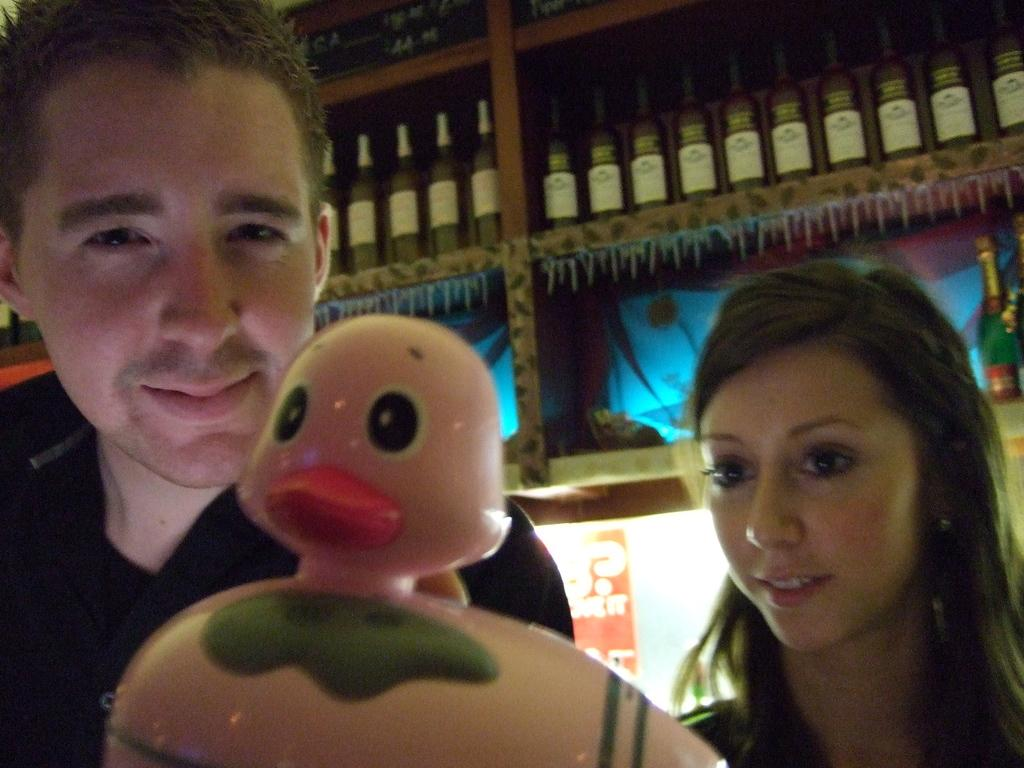Who are the people in the image? There is a woman and a man in the image. What is in front of the woman and man? There is a toy in front of the woman and man. What can be seen behind the woman and man? There is a rack visible in the image. What is stored on the rack? There are bottles in the rack. What type of authority does the woman have over the man in the image? There is no indication of authority or power dynamics between the woman and the man in the image. --- Facts: 1. There is a car in the image. 2. The car is parked on the street. 3. There are trees on both sides of the street. 4. The sky is visible in the image. 5. There are clouds in the sky. Absurd Topics: elephant, dance, ocean Conversation: What is the main subject of the image? The main subject of the image is a car. Where is the car located in the image? The car is parked on the street. What can be seen on both sides of the street? There are trees on both sides of the street. What is visible in the background of the image? The sky is visible in the image, and there are clouds in the sky. Reasoning: Let's think step by step in order to produce the conversation. We start by identifying the main subject of the image, which is the car. Then, we describe the location of the car and the surrounding environment, including the trees and the sky. Each question is designed to elicit a specific detail about the image that is known from the provided facts. Absurd Question/Answer: Can you see an elephant dancing in the ocean in the image? No, there is no elephant or ocean present in the image. 